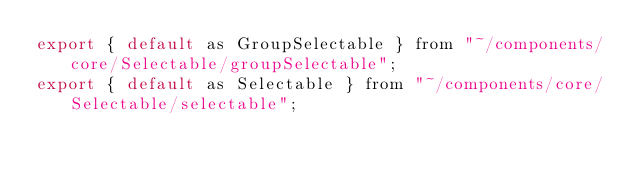Convert code to text. <code><loc_0><loc_0><loc_500><loc_500><_JavaScript_>export { default as GroupSelectable } from "~/components/core/Selectable/groupSelectable";
export { default as Selectable } from "~/components/core/Selectable/selectable";
</code> 